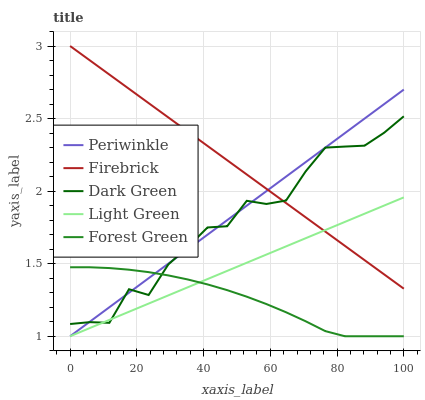Does Forest Green have the minimum area under the curve?
Answer yes or no. Yes. Does Firebrick have the maximum area under the curve?
Answer yes or no. Yes. Does Periwinkle have the minimum area under the curve?
Answer yes or no. No. Does Periwinkle have the maximum area under the curve?
Answer yes or no. No. Is Light Green the smoothest?
Answer yes or no. Yes. Is Dark Green the roughest?
Answer yes or no. Yes. Is Periwinkle the smoothest?
Answer yes or no. No. Is Periwinkle the roughest?
Answer yes or no. No. Does Periwinkle have the lowest value?
Answer yes or no. Yes. Does Dark Green have the lowest value?
Answer yes or no. No. Does Firebrick have the highest value?
Answer yes or no. Yes. Does Periwinkle have the highest value?
Answer yes or no. No. Is Forest Green less than Firebrick?
Answer yes or no. Yes. Is Firebrick greater than Forest Green?
Answer yes or no. Yes. Does Dark Green intersect Light Green?
Answer yes or no. Yes. Is Dark Green less than Light Green?
Answer yes or no. No. Is Dark Green greater than Light Green?
Answer yes or no. No. Does Forest Green intersect Firebrick?
Answer yes or no. No. 